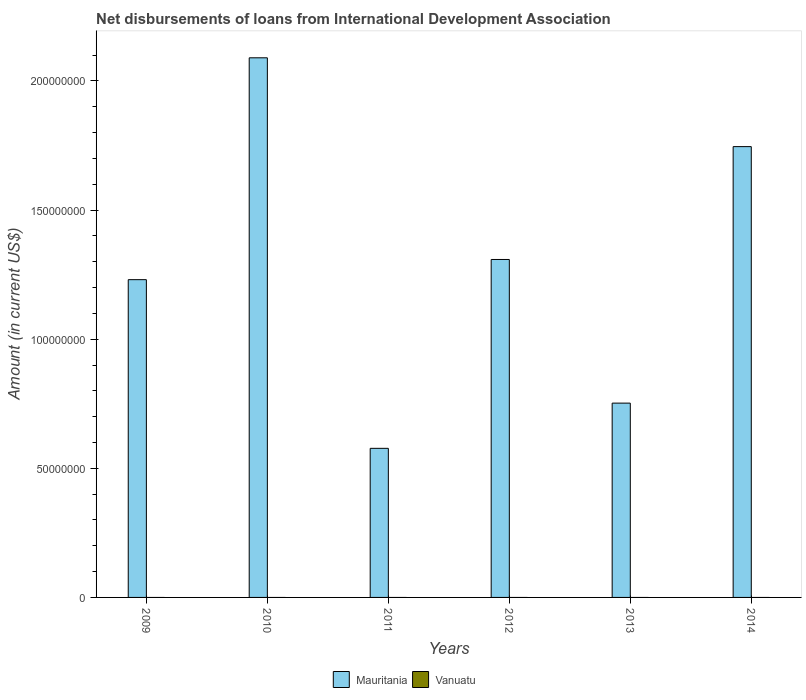Are the number of bars on each tick of the X-axis equal?
Your answer should be compact. Yes. How many bars are there on the 5th tick from the left?
Make the answer very short. 1. What is the label of the 5th group of bars from the left?
Your answer should be compact. 2013. In how many cases, is the number of bars for a given year not equal to the number of legend labels?
Your answer should be compact. 6. What is the amount of loans disbursed in Mauritania in 2013?
Your response must be concise. 7.52e+07. Across all years, what is the maximum amount of loans disbursed in Mauritania?
Your answer should be very brief. 2.09e+08. Across all years, what is the minimum amount of loans disbursed in Mauritania?
Provide a short and direct response. 5.77e+07. What is the total amount of loans disbursed in Mauritania in the graph?
Give a very brief answer. 7.70e+08. What is the difference between the amount of loans disbursed in Mauritania in 2009 and that in 2011?
Ensure brevity in your answer.  6.53e+07. What is the difference between the amount of loans disbursed in Mauritania in 2010 and the amount of loans disbursed in Vanuatu in 2012?
Keep it short and to the point. 2.09e+08. What is the average amount of loans disbursed in Mauritania per year?
Keep it short and to the point. 1.28e+08. In how many years, is the amount of loans disbursed in Vanuatu greater than 30000000 US$?
Offer a terse response. 0. What is the ratio of the amount of loans disbursed in Mauritania in 2009 to that in 2011?
Provide a short and direct response. 2.13. Is the amount of loans disbursed in Mauritania in 2009 less than that in 2012?
Ensure brevity in your answer.  Yes. What is the difference between the highest and the second highest amount of loans disbursed in Mauritania?
Your answer should be very brief. 3.44e+07. What is the difference between the highest and the lowest amount of loans disbursed in Mauritania?
Ensure brevity in your answer.  1.51e+08. Is the sum of the amount of loans disbursed in Mauritania in 2011 and 2012 greater than the maximum amount of loans disbursed in Vanuatu across all years?
Offer a terse response. Yes. How many bars are there?
Offer a very short reply. 6. What is the difference between two consecutive major ticks on the Y-axis?
Make the answer very short. 5.00e+07. Are the values on the major ticks of Y-axis written in scientific E-notation?
Your response must be concise. No. Does the graph contain grids?
Your answer should be very brief. No. Where does the legend appear in the graph?
Provide a short and direct response. Bottom center. How are the legend labels stacked?
Offer a terse response. Horizontal. What is the title of the graph?
Give a very brief answer. Net disbursements of loans from International Development Association. What is the Amount (in current US$) in Mauritania in 2009?
Offer a terse response. 1.23e+08. What is the Amount (in current US$) of Vanuatu in 2009?
Offer a very short reply. 0. What is the Amount (in current US$) in Mauritania in 2010?
Your answer should be compact. 2.09e+08. What is the Amount (in current US$) of Vanuatu in 2010?
Make the answer very short. 0. What is the Amount (in current US$) in Mauritania in 2011?
Ensure brevity in your answer.  5.77e+07. What is the Amount (in current US$) in Mauritania in 2012?
Your response must be concise. 1.31e+08. What is the Amount (in current US$) of Vanuatu in 2012?
Offer a terse response. 0. What is the Amount (in current US$) of Mauritania in 2013?
Your answer should be very brief. 7.52e+07. What is the Amount (in current US$) of Vanuatu in 2013?
Your response must be concise. 0. What is the Amount (in current US$) of Mauritania in 2014?
Keep it short and to the point. 1.75e+08. What is the Amount (in current US$) in Vanuatu in 2014?
Your answer should be compact. 0. Across all years, what is the maximum Amount (in current US$) of Mauritania?
Give a very brief answer. 2.09e+08. Across all years, what is the minimum Amount (in current US$) of Mauritania?
Offer a terse response. 5.77e+07. What is the total Amount (in current US$) of Mauritania in the graph?
Provide a succinct answer. 7.70e+08. What is the total Amount (in current US$) in Vanuatu in the graph?
Offer a terse response. 0. What is the difference between the Amount (in current US$) of Mauritania in 2009 and that in 2010?
Your answer should be compact. -8.59e+07. What is the difference between the Amount (in current US$) of Mauritania in 2009 and that in 2011?
Offer a very short reply. 6.53e+07. What is the difference between the Amount (in current US$) in Mauritania in 2009 and that in 2012?
Your answer should be compact. -7.81e+06. What is the difference between the Amount (in current US$) in Mauritania in 2009 and that in 2013?
Your answer should be very brief. 4.78e+07. What is the difference between the Amount (in current US$) in Mauritania in 2009 and that in 2014?
Offer a terse response. -5.15e+07. What is the difference between the Amount (in current US$) of Mauritania in 2010 and that in 2011?
Give a very brief answer. 1.51e+08. What is the difference between the Amount (in current US$) of Mauritania in 2010 and that in 2012?
Your response must be concise. 7.81e+07. What is the difference between the Amount (in current US$) in Mauritania in 2010 and that in 2013?
Provide a short and direct response. 1.34e+08. What is the difference between the Amount (in current US$) of Mauritania in 2010 and that in 2014?
Provide a short and direct response. 3.44e+07. What is the difference between the Amount (in current US$) in Mauritania in 2011 and that in 2012?
Provide a succinct answer. -7.31e+07. What is the difference between the Amount (in current US$) in Mauritania in 2011 and that in 2013?
Keep it short and to the point. -1.75e+07. What is the difference between the Amount (in current US$) in Mauritania in 2011 and that in 2014?
Your answer should be compact. -1.17e+08. What is the difference between the Amount (in current US$) in Mauritania in 2012 and that in 2013?
Keep it short and to the point. 5.56e+07. What is the difference between the Amount (in current US$) of Mauritania in 2012 and that in 2014?
Your answer should be compact. -4.37e+07. What is the difference between the Amount (in current US$) in Mauritania in 2013 and that in 2014?
Give a very brief answer. -9.93e+07. What is the average Amount (in current US$) in Mauritania per year?
Your response must be concise. 1.28e+08. What is the average Amount (in current US$) in Vanuatu per year?
Provide a short and direct response. 0. What is the ratio of the Amount (in current US$) of Mauritania in 2009 to that in 2010?
Ensure brevity in your answer.  0.59. What is the ratio of the Amount (in current US$) in Mauritania in 2009 to that in 2011?
Offer a terse response. 2.13. What is the ratio of the Amount (in current US$) of Mauritania in 2009 to that in 2012?
Provide a short and direct response. 0.94. What is the ratio of the Amount (in current US$) in Mauritania in 2009 to that in 2013?
Offer a terse response. 1.64. What is the ratio of the Amount (in current US$) in Mauritania in 2009 to that in 2014?
Provide a short and direct response. 0.7. What is the ratio of the Amount (in current US$) of Mauritania in 2010 to that in 2011?
Keep it short and to the point. 3.62. What is the ratio of the Amount (in current US$) in Mauritania in 2010 to that in 2012?
Ensure brevity in your answer.  1.6. What is the ratio of the Amount (in current US$) of Mauritania in 2010 to that in 2013?
Ensure brevity in your answer.  2.78. What is the ratio of the Amount (in current US$) in Mauritania in 2010 to that in 2014?
Your response must be concise. 1.2. What is the ratio of the Amount (in current US$) in Mauritania in 2011 to that in 2012?
Keep it short and to the point. 0.44. What is the ratio of the Amount (in current US$) of Mauritania in 2011 to that in 2013?
Offer a terse response. 0.77. What is the ratio of the Amount (in current US$) of Mauritania in 2011 to that in 2014?
Your answer should be compact. 0.33. What is the ratio of the Amount (in current US$) of Mauritania in 2012 to that in 2013?
Your response must be concise. 1.74. What is the ratio of the Amount (in current US$) of Mauritania in 2012 to that in 2014?
Offer a very short reply. 0.75. What is the ratio of the Amount (in current US$) of Mauritania in 2013 to that in 2014?
Your answer should be compact. 0.43. What is the difference between the highest and the second highest Amount (in current US$) of Mauritania?
Give a very brief answer. 3.44e+07. What is the difference between the highest and the lowest Amount (in current US$) in Mauritania?
Offer a terse response. 1.51e+08. 